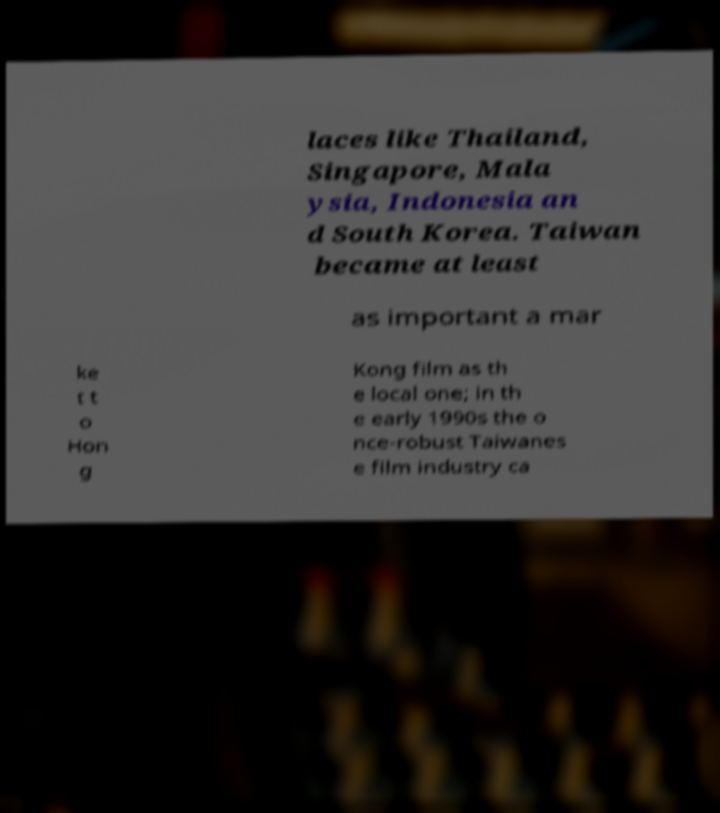I need the written content from this picture converted into text. Can you do that? laces like Thailand, Singapore, Mala ysia, Indonesia an d South Korea. Taiwan became at least as important a mar ke t t o Hon g Kong film as th e local one; in th e early 1990s the o nce-robust Taiwanes e film industry ca 